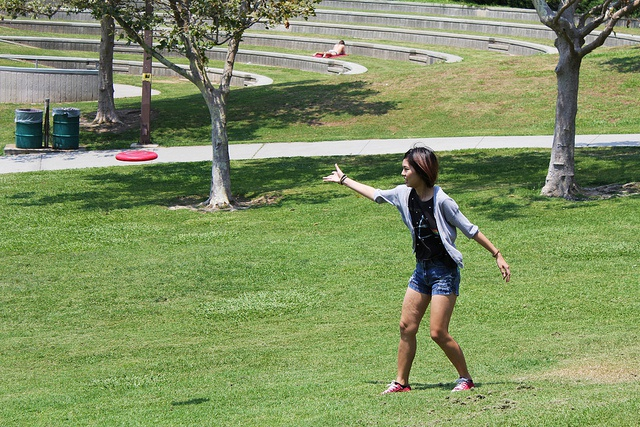Describe the objects in this image and their specific colors. I can see people in olive, black, lavender, maroon, and gray tones, frisbee in olive, salmon, lightpink, and maroon tones, and people in olive, lightgray, brown, and tan tones in this image. 